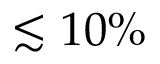Convert formula to latex. <formula><loc_0><loc_0><loc_500><loc_500>\lesssim 1 0 \%</formula> 